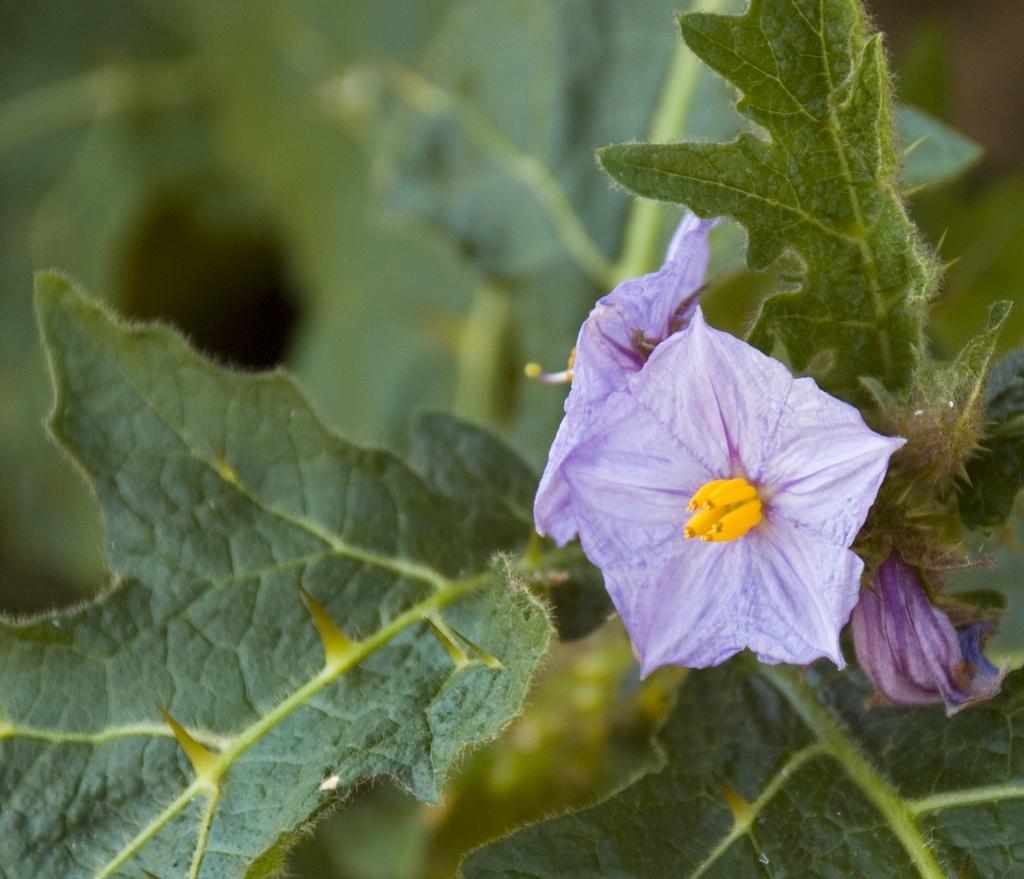Could you give a brief overview of what you see in this image? In this image we can see flowers, plant, and the background is blurred. 